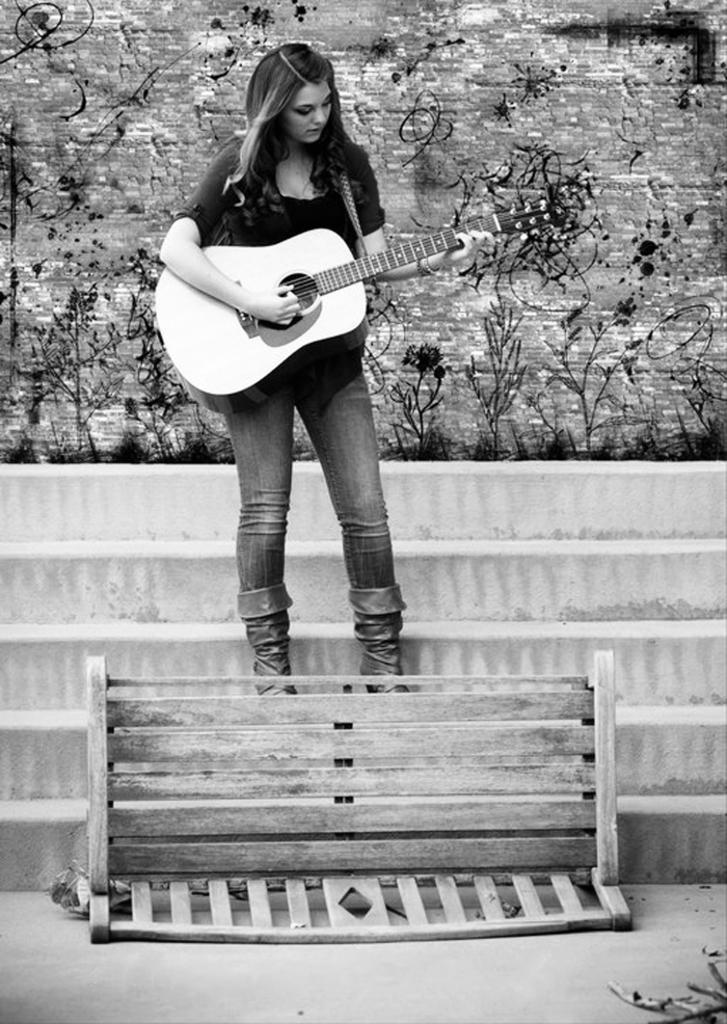Could you give a brief overview of what you see in this image? As we can see in a picture a woman is standing and holding a guitar in her hand. These are the stairs, bench, plant. 